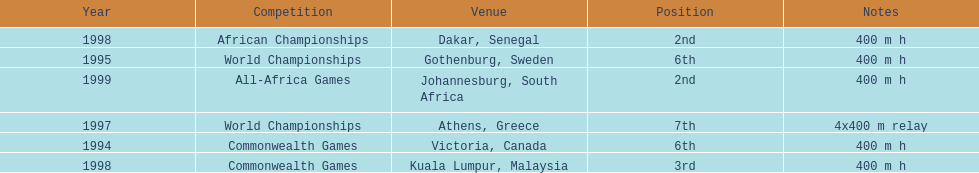Which year had the most competitions? 1998. 